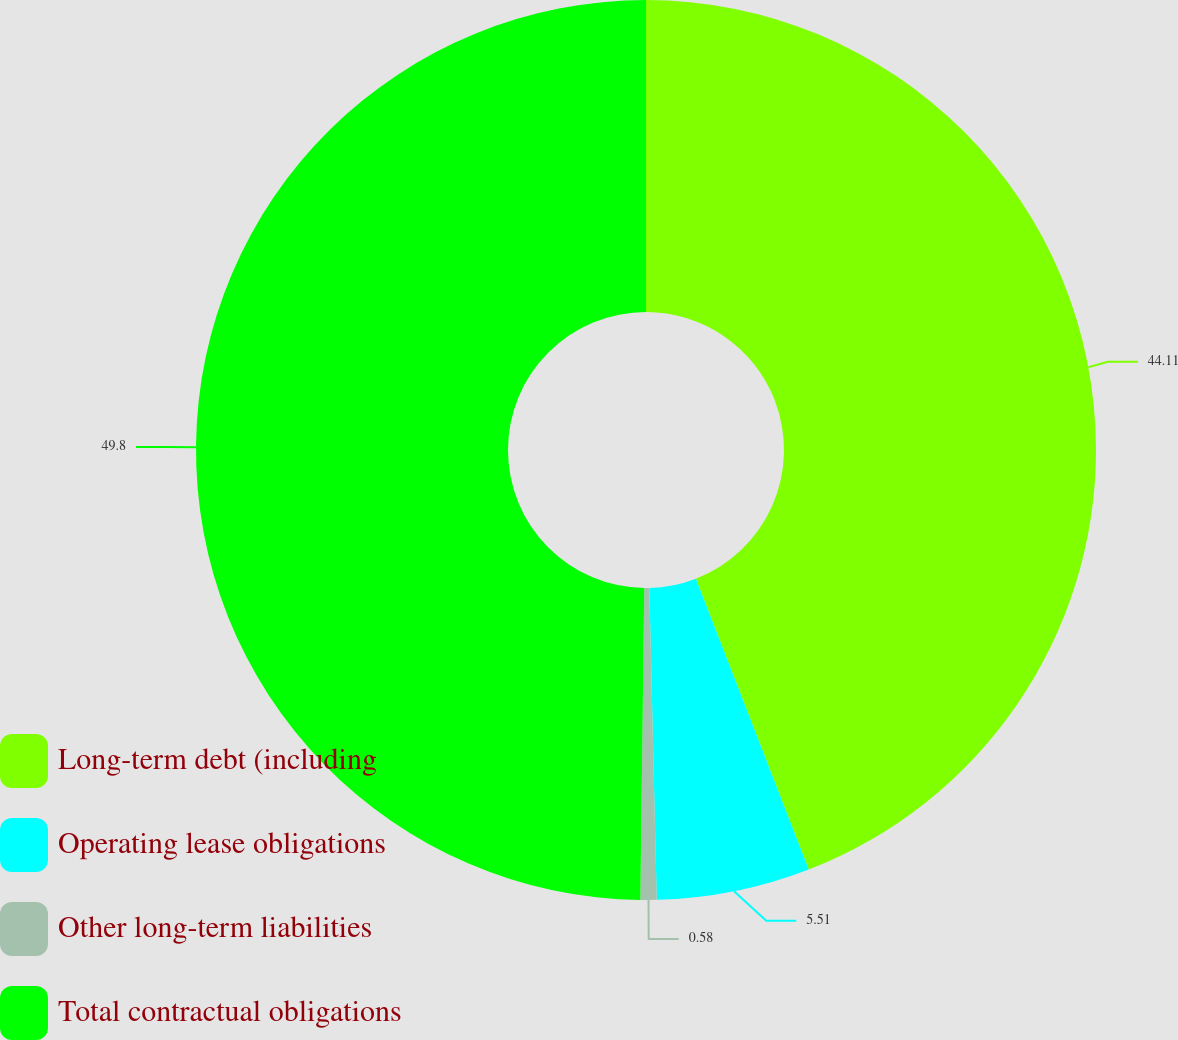<chart> <loc_0><loc_0><loc_500><loc_500><pie_chart><fcel>Long-term debt (including<fcel>Operating lease obligations<fcel>Other long-term liabilities<fcel>Total contractual obligations<nl><fcel>44.11%<fcel>5.51%<fcel>0.58%<fcel>49.8%<nl></chart> 